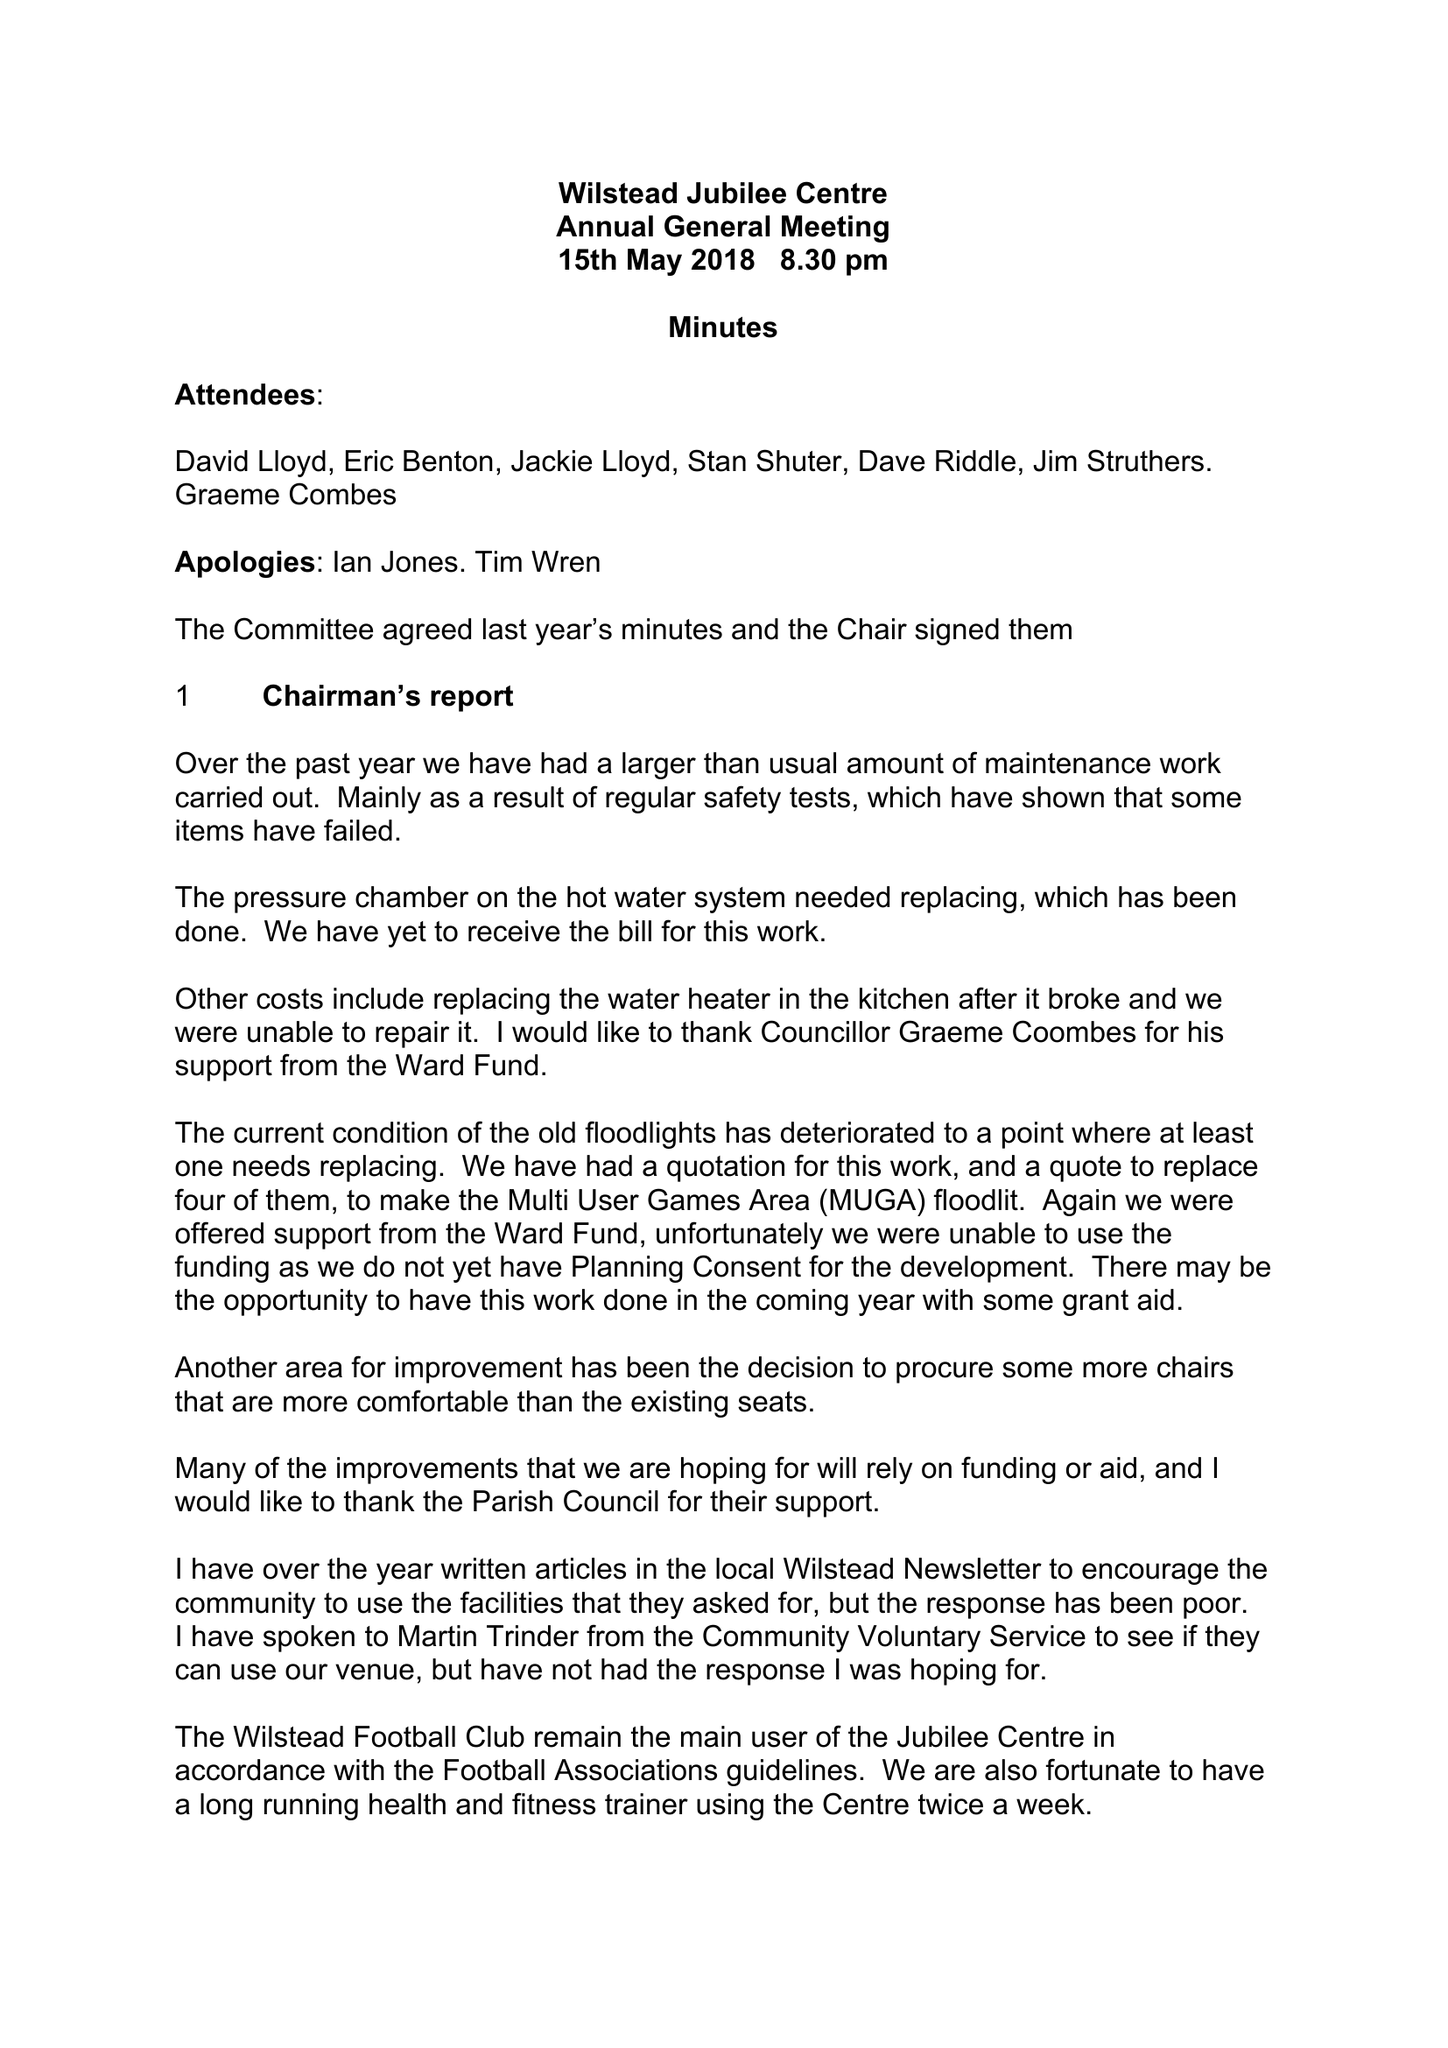What is the value for the charity_name?
Answer the question using a single word or phrase. Wilstead Jubilee Centre 